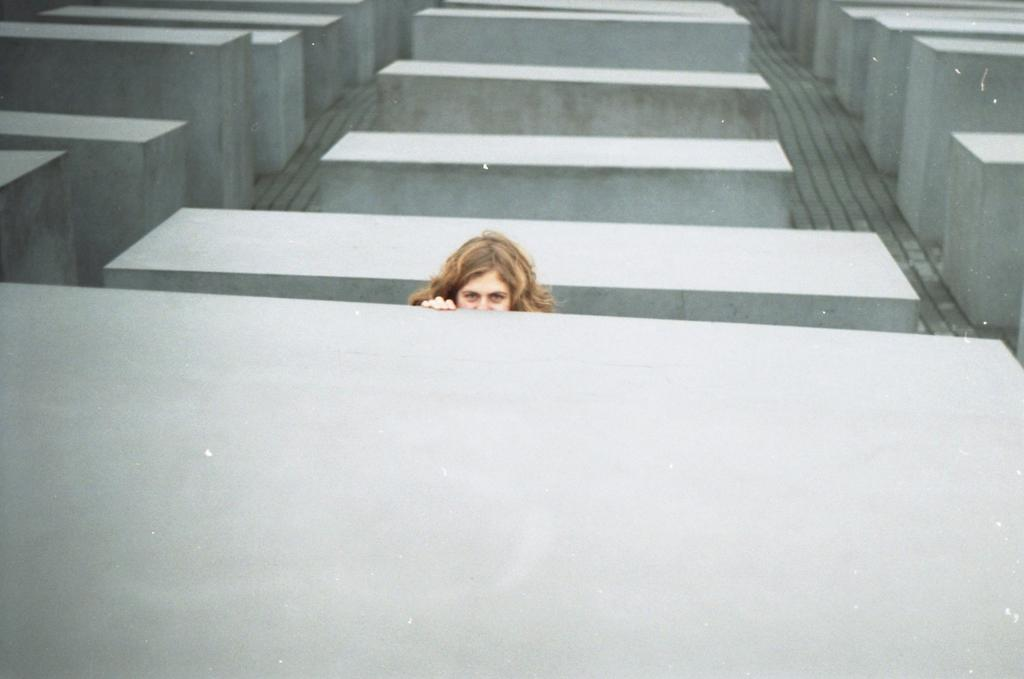What type of structures are present in the image? There are concrete boxes in the image. What color are the concrete boxes? The concrete boxes are grey in color. Can you identify any human elements in the image? Yes, there is a person's face visible in the image. What type of bells can be heard ringing in the image? There are no bells present in the image, and therefore no sounds can be heard. 